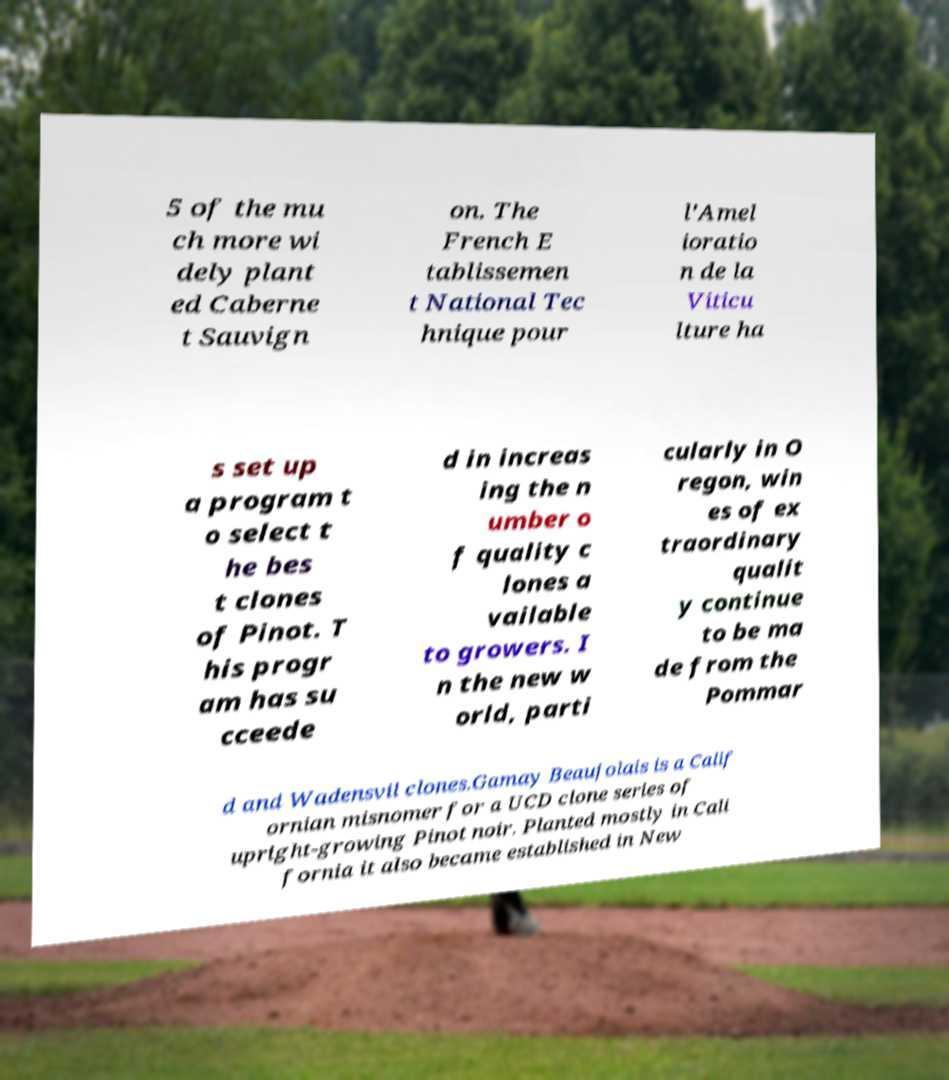For documentation purposes, I need the text within this image transcribed. Could you provide that? 5 of the mu ch more wi dely plant ed Caberne t Sauvign on. The French E tablissemen t National Tec hnique pour l'Amel ioratio n de la Viticu lture ha s set up a program t o select t he bes t clones of Pinot. T his progr am has su cceede d in increas ing the n umber o f quality c lones a vailable to growers. I n the new w orld, parti cularly in O regon, win es of ex traordinary qualit y continue to be ma de from the Pommar d and Wadensvil clones.Gamay Beaujolais is a Calif ornian misnomer for a UCD clone series of upright-growing Pinot noir. Planted mostly in Cali fornia it also became established in New 